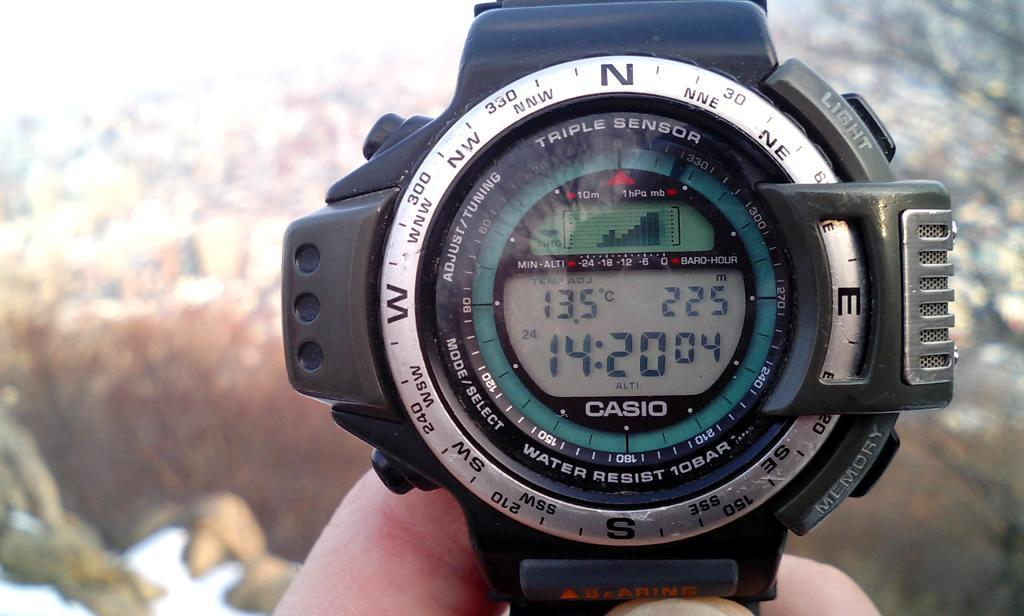<image>
Present a compact description of the photo's key features. A Casio watch shows that the time is now 14:20. 